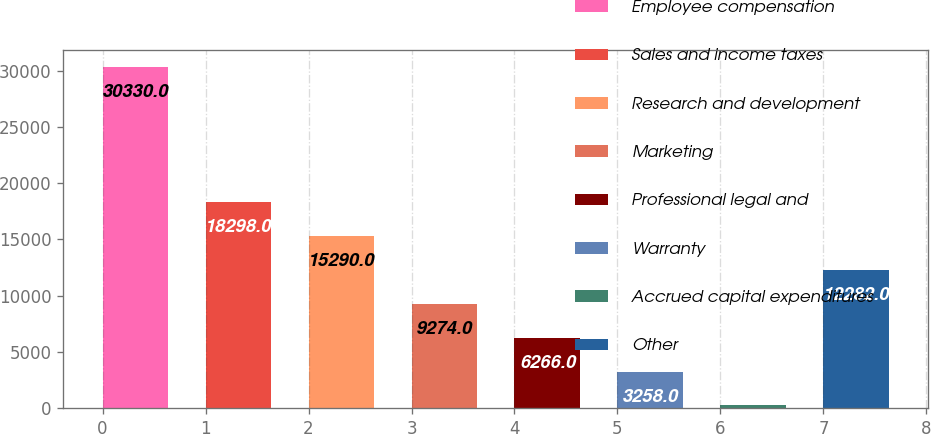Convert chart. <chart><loc_0><loc_0><loc_500><loc_500><bar_chart><fcel>Employee compensation<fcel>Sales and income taxes<fcel>Research and development<fcel>Marketing<fcel>Professional legal and<fcel>Warranty<fcel>Accrued capital expenditures<fcel>Other<nl><fcel>30330<fcel>18298<fcel>15290<fcel>9274<fcel>6266<fcel>3258<fcel>250<fcel>12282<nl></chart> 